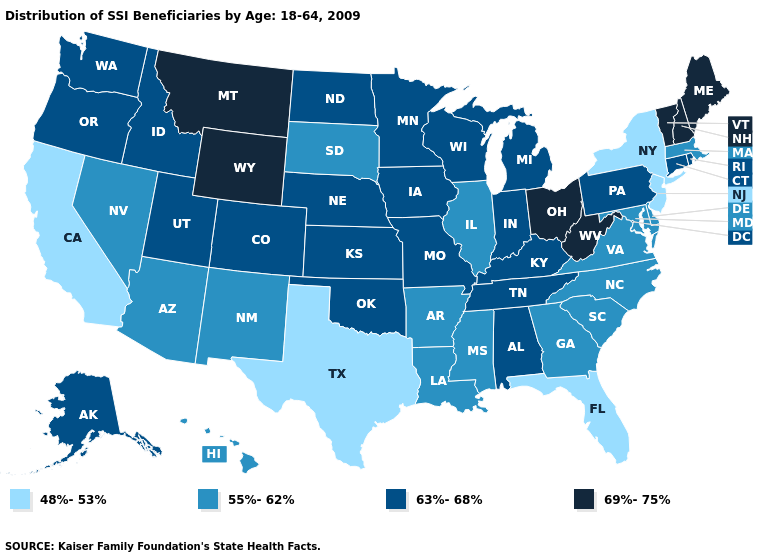Name the states that have a value in the range 69%-75%?
Short answer required. Maine, Montana, New Hampshire, Ohio, Vermont, West Virginia, Wyoming. Which states have the highest value in the USA?
Answer briefly. Maine, Montana, New Hampshire, Ohio, Vermont, West Virginia, Wyoming. Which states have the lowest value in the USA?
Answer briefly. California, Florida, New Jersey, New York, Texas. What is the highest value in states that border Alabama?
Give a very brief answer. 63%-68%. What is the lowest value in the MidWest?
Keep it brief. 55%-62%. What is the value of Ohio?
Keep it brief. 69%-75%. What is the lowest value in states that border Montana?
Quick response, please. 55%-62%. What is the value of Wyoming?
Short answer required. 69%-75%. Which states have the highest value in the USA?
Keep it brief. Maine, Montana, New Hampshire, Ohio, Vermont, West Virginia, Wyoming. What is the value of Nebraska?
Give a very brief answer. 63%-68%. What is the value of Iowa?
Concise answer only. 63%-68%. Does North Carolina have the highest value in the USA?
Give a very brief answer. No. Does Michigan have the lowest value in the MidWest?
Be succinct. No. What is the value of Utah?
Keep it brief. 63%-68%. Is the legend a continuous bar?
Short answer required. No. 